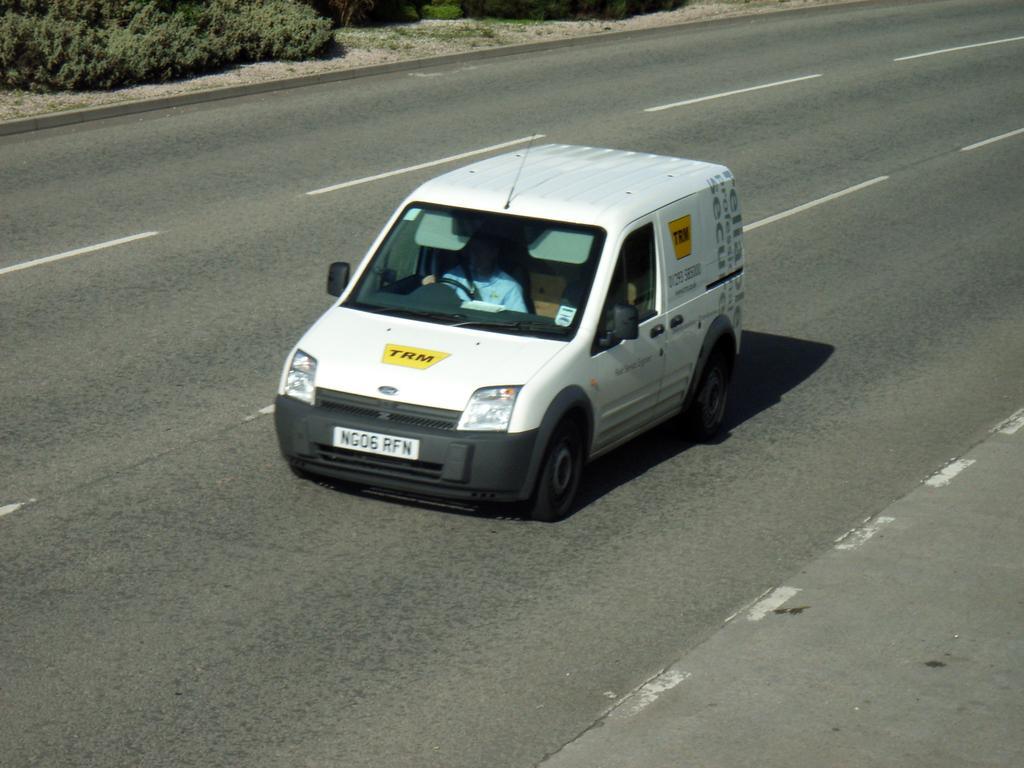Could you give a brief overview of what you see in this image? In this picture we can see a vehicle on the road with a person sitting in it and in the background we can see plants on the ground. 